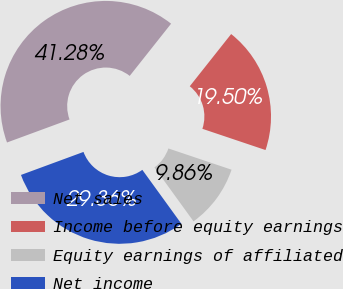Convert chart to OTSL. <chart><loc_0><loc_0><loc_500><loc_500><pie_chart><fcel>Net sales<fcel>Income before equity earnings<fcel>Equity earnings of affiliated<fcel>Net income<nl><fcel>41.28%<fcel>19.5%<fcel>9.86%<fcel>29.36%<nl></chart> 